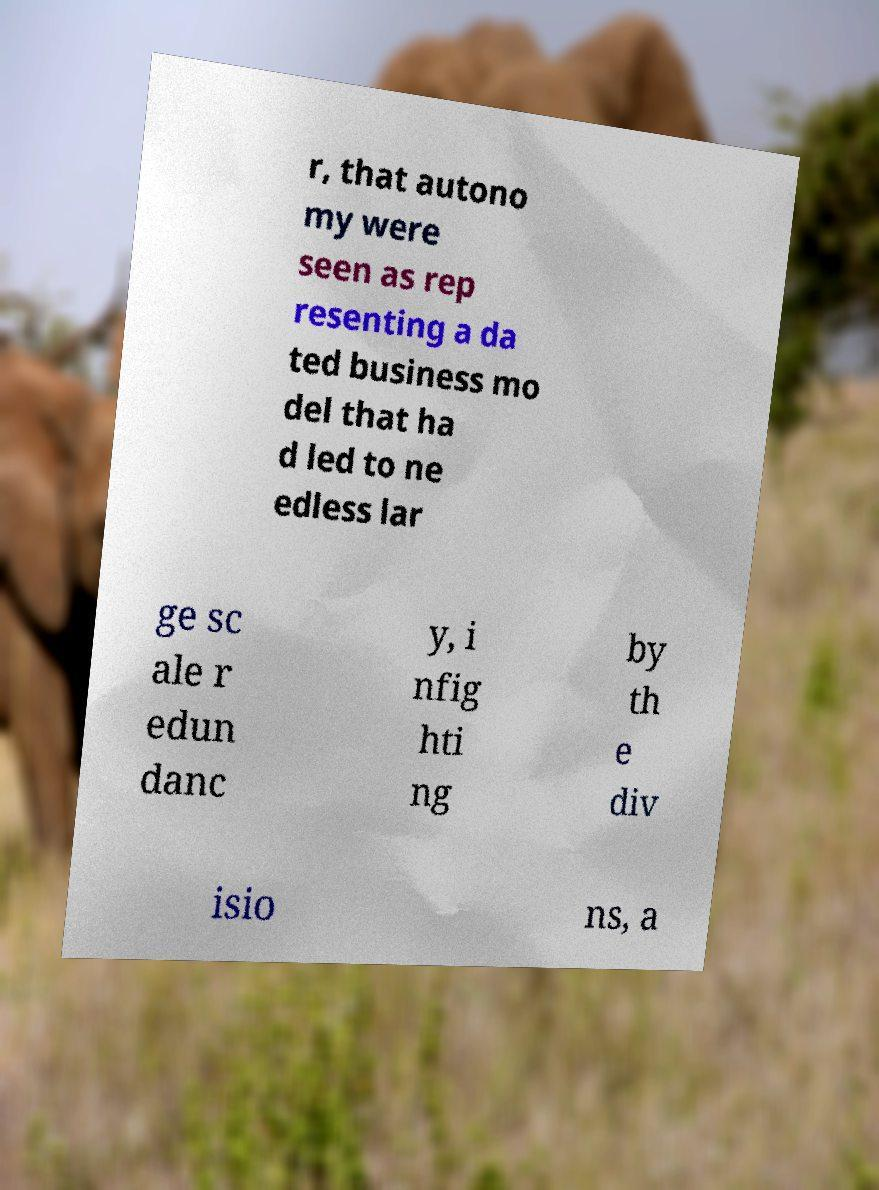Could you assist in decoding the text presented in this image and type it out clearly? r, that autono my were seen as rep resenting a da ted business mo del that ha d led to ne edless lar ge sc ale r edun danc y, i nfig hti ng by th e div isio ns, a 